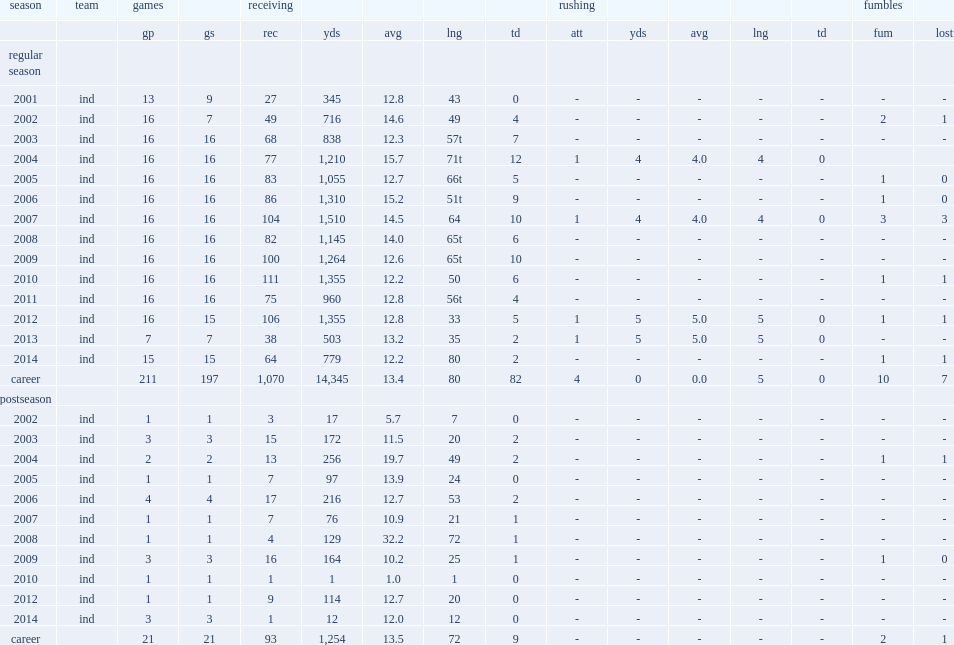In 2007, how many receptions did wayne score? 104.0. In 2007, how many yards did wayne score? 1510.0. 